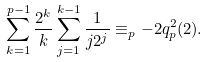Convert formula to latex. <formula><loc_0><loc_0><loc_500><loc_500>\sum _ { k = 1 } ^ { p - 1 } \frac { 2 ^ { k } } { k } \sum _ { j = 1 } ^ { k - 1 } \frac { 1 } { j 2 ^ { j } } \equiv _ { p } - 2 q ^ { 2 } _ { p } ( 2 ) .</formula> 